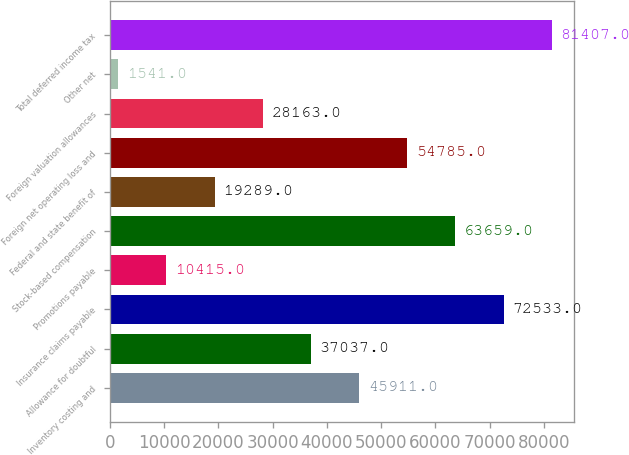Convert chart to OTSL. <chart><loc_0><loc_0><loc_500><loc_500><bar_chart><fcel>Inventory costing and<fcel>Allowance for doubtful<fcel>Insurance claims payable<fcel>Promotions payable<fcel>Stock-based compensation<fcel>Federal and state benefit of<fcel>Foreign net operating loss and<fcel>Foreign valuation allowances<fcel>Other net<fcel>Total deferred income tax<nl><fcel>45911<fcel>37037<fcel>72533<fcel>10415<fcel>63659<fcel>19289<fcel>54785<fcel>28163<fcel>1541<fcel>81407<nl></chart> 